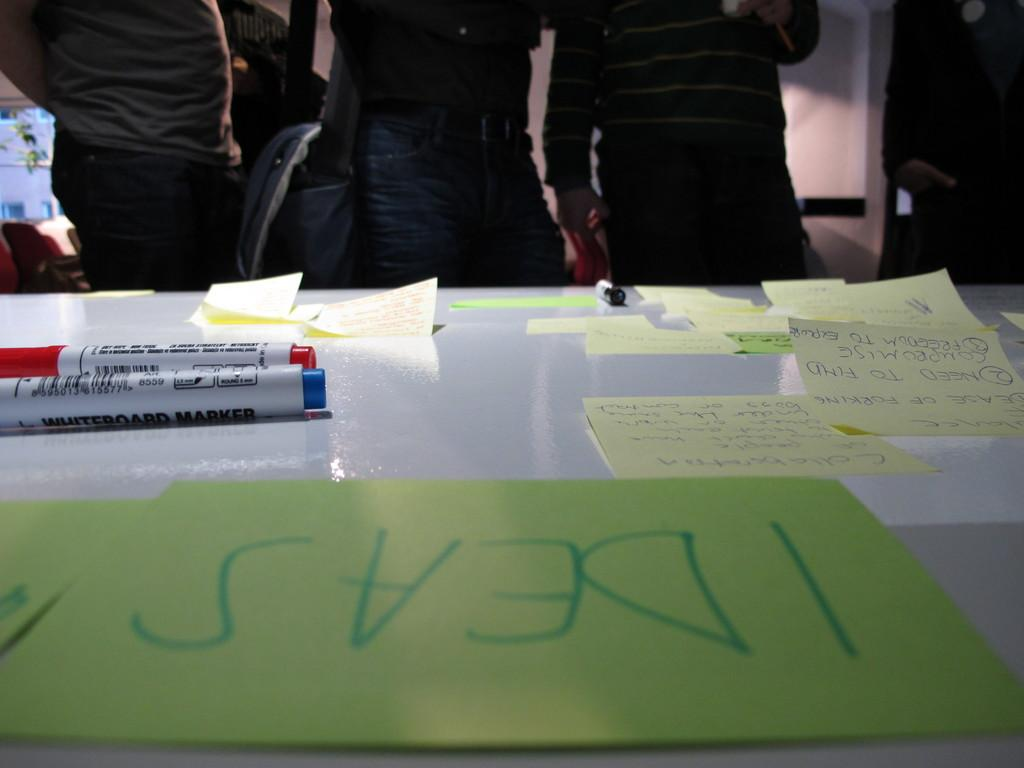What type of table is in the image? There is a white table in the image. What items are on the table? There are markers and sticky notes with text on the table. Can you describe the people in the background of the image? People are standing near chairs in the background of the image. What is the profit margin of the iron store downtown in the image? There is no mention of an iron store or profit margin in the image; it features a white table with markers and sticky notes. 